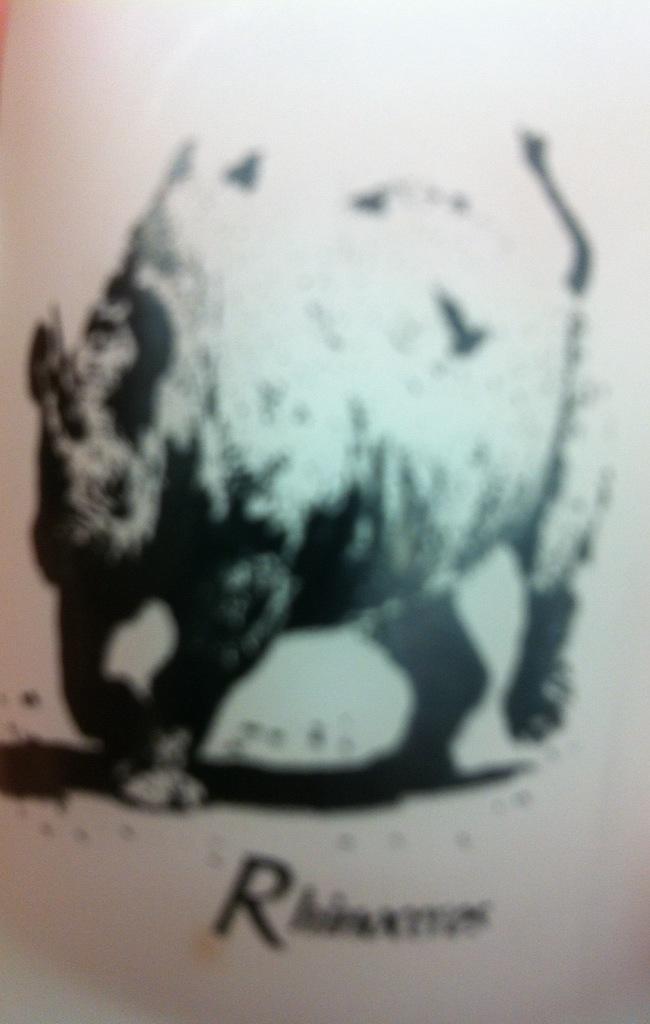How would you summarize this image in a sentence or two? It is a poster. In this image there is a depiction of a hippopotamus and there is some text on the bottom of the image. 